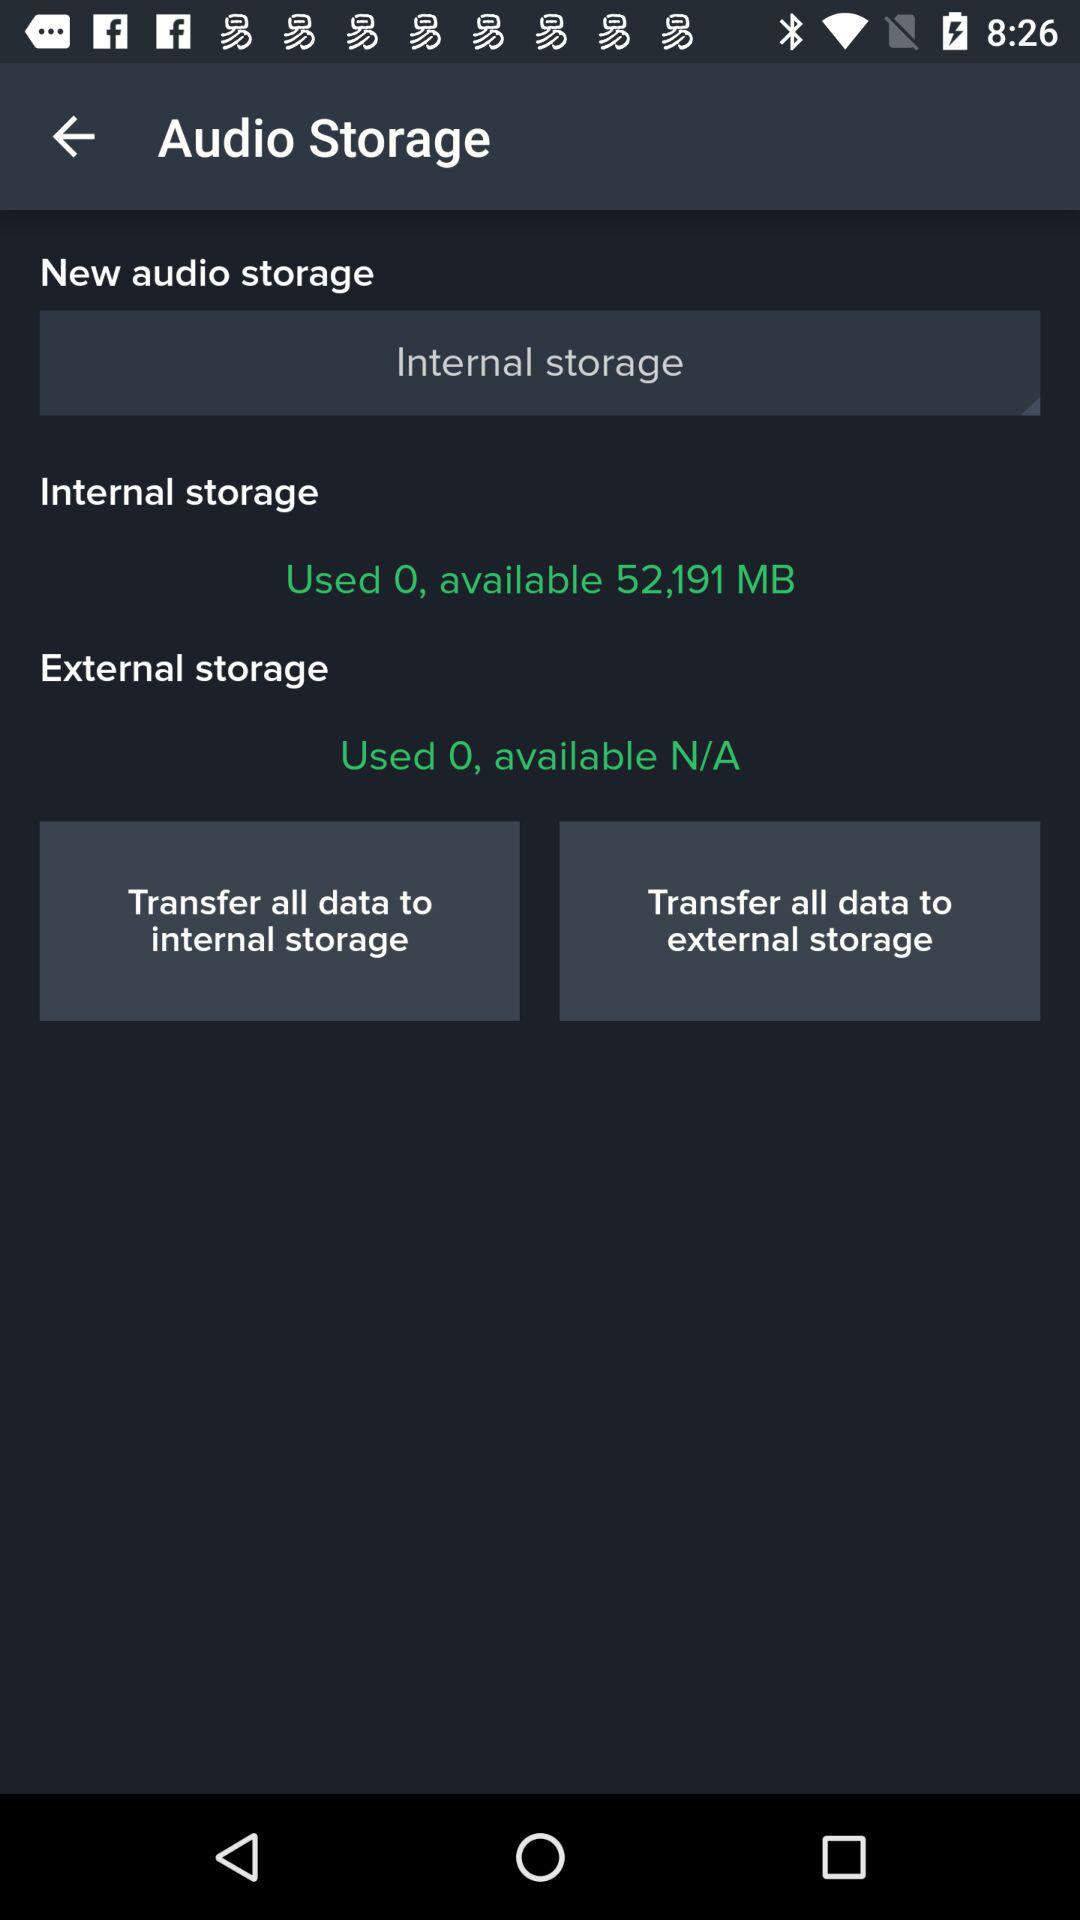How much internal storage is available? The available internal storage is 52,191 MB. 